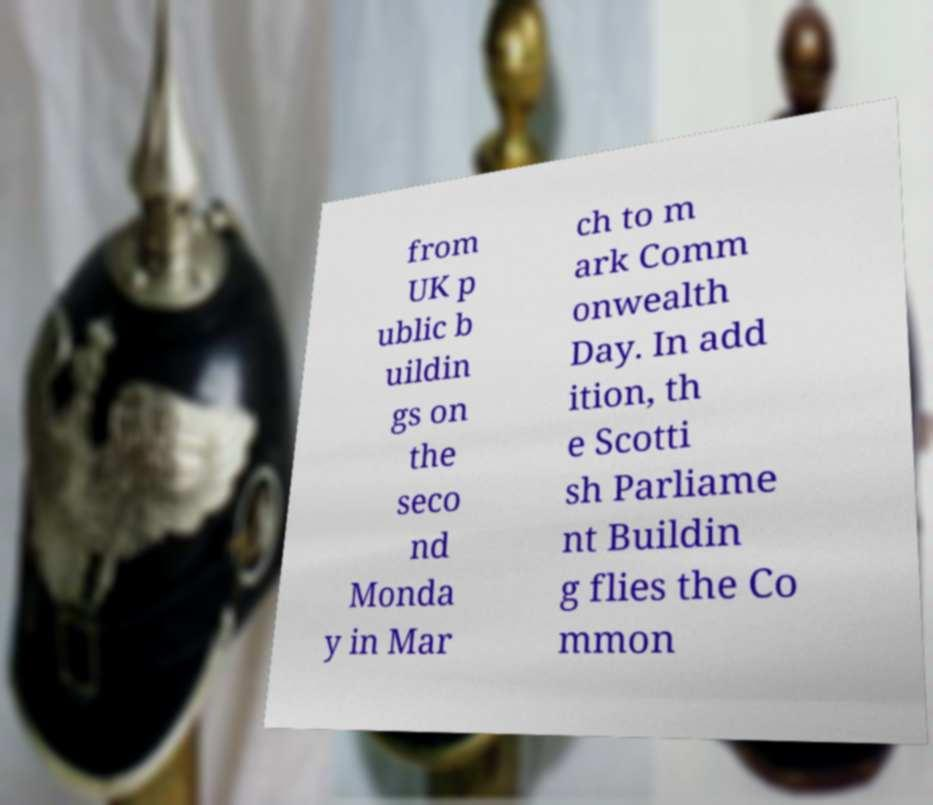There's text embedded in this image that I need extracted. Can you transcribe it verbatim? from UK p ublic b uildin gs on the seco nd Monda y in Mar ch to m ark Comm onwealth Day. In add ition, th e Scotti sh Parliame nt Buildin g flies the Co mmon 